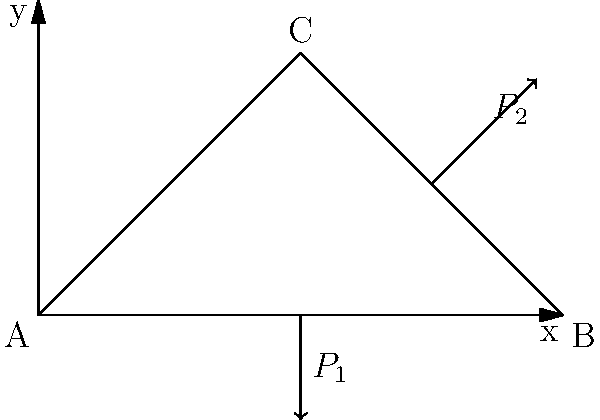As a college representative developing educational programs for veterans, you're tasked with creating a problem that demonstrates the practical application of structural analysis. Consider the truss bridge structure shown above, subjected to two point loads: a vertical load $P_1$ at the midpoint of member AB and a diagonal load $P_2$ acting on member BC. How would the stress distribution in the truss members change if load $P_2$ were to be removed? Explain the impact on each member and identify which member(s) would experience the most significant change in stress. To analyze the stress distribution change, we'll follow these steps:

1. Initial condition (with both loads):
   - Member AB: Experiences both compression and bending due to $P_1$ and the horizontal component of $P_2$.
   - Member BC: Under tension due to $P_2$ and the reaction from $P_1$.
   - Member AC: Under compression to balance the vertical components of forces.

2. Condition after removing $P_2$:
   - Member AB: Will still experience bending due to $P_1$, but the axial compression will decrease.
   - Member BC: The tension will significantly decrease, as $P_2$ was directly applying tension to this member.
   - Member AC: The compression will decrease, as it no longer needs to counteract the vertical component of $P_2$.

3. Most significant change:
   - Member BC will experience the most significant change, as the removal of $P_2$ directly affects its tension state.

4. Practical implications:
   - This scenario demonstrates how load redistribution affects structural integrity, a crucial concept in bridge design and maintenance.

5. Relevance to veterans' education:
   - This problem illustrates the importance of understanding load paths and structural behavior, which is valuable in military engineering applications and civilian infrastructure projects that veterans might encounter in their careers.
Answer: Member BC experiences the most significant stress change, with greatly reduced tension. 